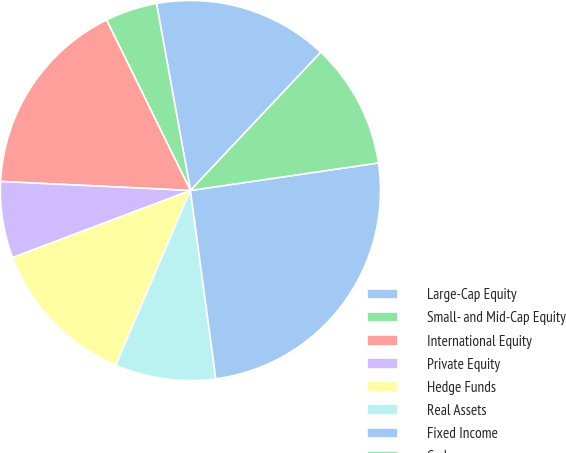<chart> <loc_0><loc_0><loc_500><loc_500><pie_chart><fcel>Large-Cap Equity<fcel>Small- and Mid-Cap Equity<fcel>International Equity<fcel>Private Equity<fcel>Hedge Funds<fcel>Real Assets<fcel>Fixed Income<fcel>Cash<nl><fcel>14.89%<fcel>4.42%<fcel>16.97%<fcel>6.5%<fcel>12.82%<fcel>8.57%<fcel>25.18%<fcel>10.65%<nl></chart> 